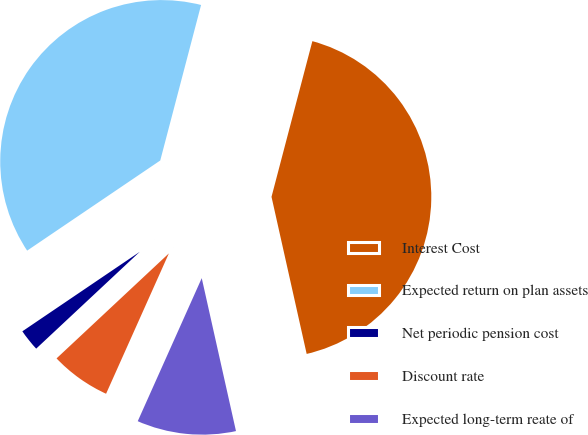<chart> <loc_0><loc_0><loc_500><loc_500><pie_chart><fcel>Interest Cost<fcel>Expected return on plan assets<fcel>Net periodic pension cost<fcel>Discount rate<fcel>Expected long-term reate of<nl><fcel>42.41%<fcel>38.56%<fcel>2.49%<fcel>6.34%<fcel>10.2%<nl></chart> 